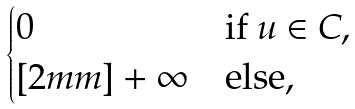Convert formula to latex. <formula><loc_0><loc_0><loc_500><loc_500>\begin{cases} 0 & \text {if } u \in C , \\ [ 2 m m ] + \infty & \text {else,} \end{cases}</formula> 